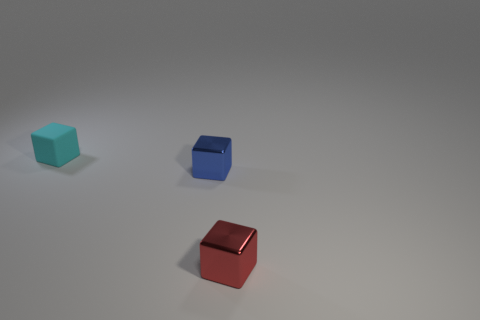How would you associate each object with a season of the year? The cool hue of the teal cube might evoke the winter season; the blue cube could symbolize the lushness and depth of summer; and the red cube may represent the fiery tones of autumn. 